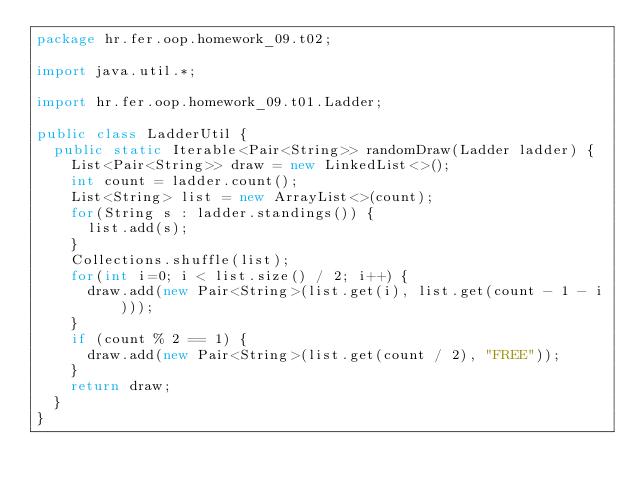Convert code to text. <code><loc_0><loc_0><loc_500><loc_500><_Java_>package hr.fer.oop.homework_09.t02;

import java.util.*;

import hr.fer.oop.homework_09.t01.Ladder;

public class LadderUtil {
	public static Iterable<Pair<String>> randomDraw(Ladder ladder) {
		List<Pair<String>> draw = new LinkedList<>();
		int count = ladder.count();
		List<String> list = new ArrayList<>(count);
		for(String s : ladder.standings()) {
			list.add(s);
		}
		Collections.shuffle(list);
		for(int i=0; i < list.size() / 2; i++) {
			draw.add(new Pair<String>(list.get(i), list.get(count - 1 - i)));
		}
		if (count % 2 == 1) {
			draw.add(new Pair<String>(list.get(count / 2), "FREE"));
		}
		return draw;
	}
}
</code> 